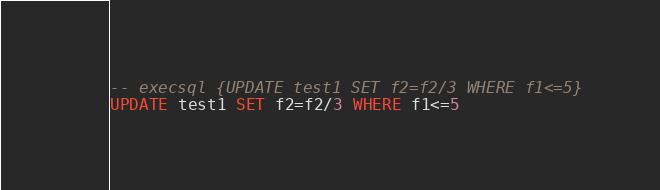Convert code to text. <code><loc_0><loc_0><loc_500><loc_500><_SQL_>-- execsql {UPDATE test1 SET f2=f2/3 WHERE f1<=5}
UPDATE test1 SET f2=f2/3 WHERE f1<=5</code> 